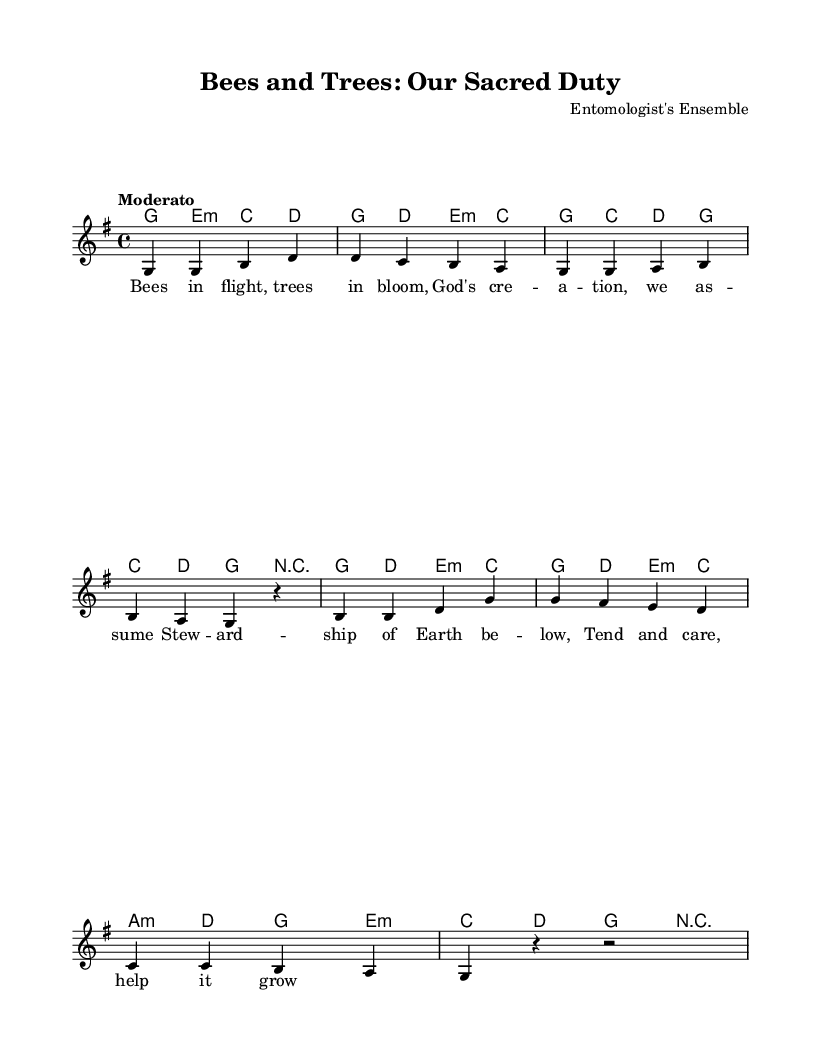What is the key signature of this music? The key signature indicates G major, which has one sharp (F#). This can be identified in the key signature section at the beginning of the score.
Answer: G major What is the time signature of this music? The time signature is 4/4, meaning there are four beats per measure and a quarter note gets one beat. This can be located at the beginning of the piece immediately following the key signature.
Answer: 4/4 What is the tempo marking for this piece? The tempo marking is "Moderato," which suggests a moderate pace for the performance. This is typically indicated above the musical staff at the start of the score.
Answer: Moderato How many measures are there in the melody? By counting the grouped notes separated by bars in the melody line, there are 8 measures present. This can be done visually by looking at the divisions in the melody section.
Answer: 8 What is the title of this piece? The title can be found at the top of the score under the header section, presenting the name of the composition. The title is "Bees and Trees: Our Sacred Duty."
Answer: Bees and Trees: Our Sacred Duty What lyrical theme does this song express? The lyrics depict stewardship of Earth and caring for creation, specifically mentioning bees and trees. By analyzing the content of the verse provided, we can see that the song focuses on the responsibility humans have for the environment.
Answer: Stewardship of Earth What type of music is "Bees and Trees: Our Sacred Duty"? Given the lyrics and context about stewardship, this piece can be classified as a Contemporary Christian song. This classification can be derived from the themes commonly associated with this genre of music, particularly its focus on faith and care for creation.
Answer: Contemporary Christian 